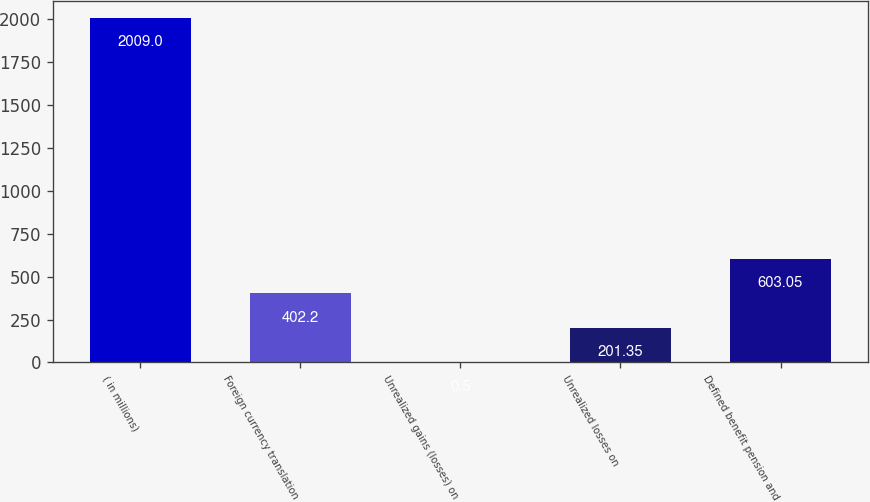Convert chart. <chart><loc_0><loc_0><loc_500><loc_500><bar_chart><fcel>( in millions)<fcel>Foreign currency translation<fcel>Unrealized gains (losses) on<fcel>Unrealized losses on<fcel>Defined benefit pension and<nl><fcel>2009<fcel>402.2<fcel>0.5<fcel>201.35<fcel>603.05<nl></chart> 